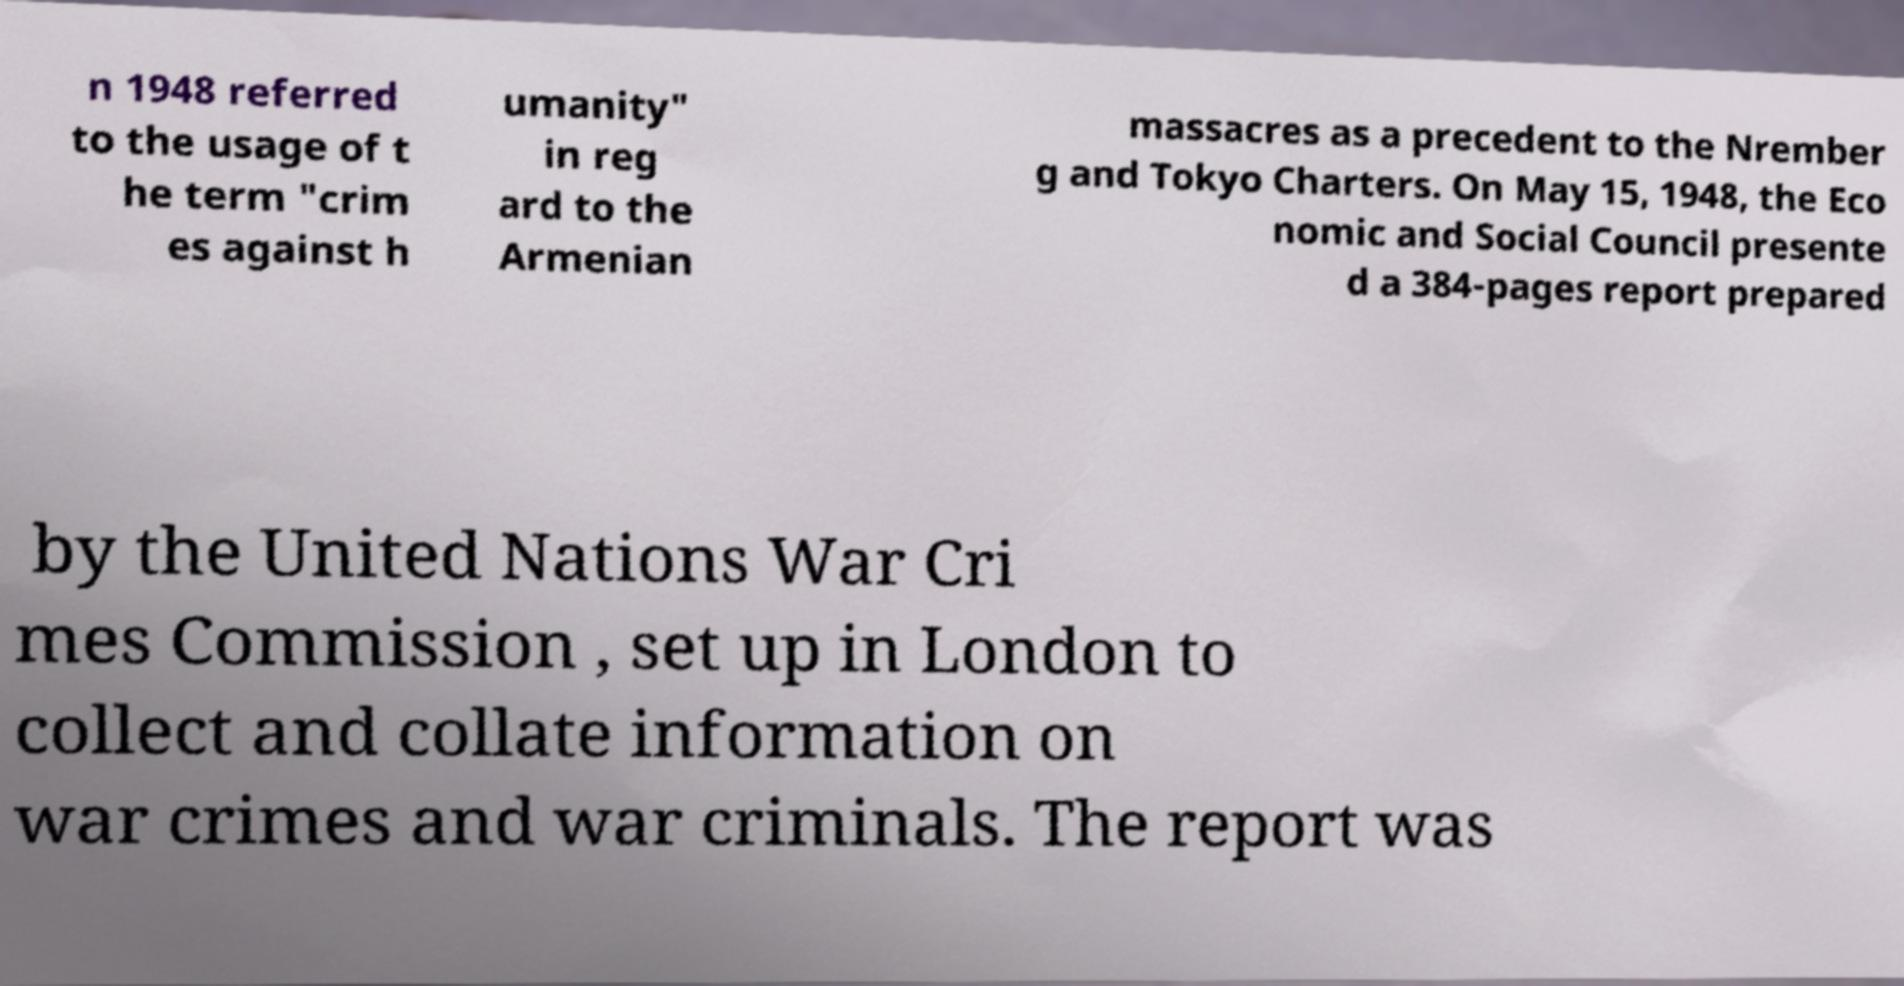Please identify and transcribe the text found in this image. n 1948 referred to the usage of t he term "crim es against h umanity" in reg ard to the Armenian massacres as a precedent to the Nrember g and Tokyo Charters. On May 15, 1948, the Eco nomic and Social Council presente d a 384-pages report prepared by the United Nations War Cri mes Commission , set up in London to collect and collate information on war crimes and war criminals. The report was 